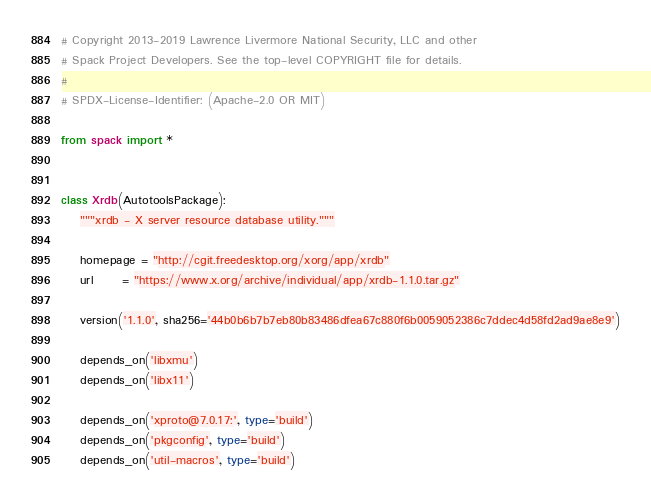<code> <loc_0><loc_0><loc_500><loc_500><_Python_># Copyright 2013-2019 Lawrence Livermore National Security, LLC and other
# Spack Project Developers. See the top-level COPYRIGHT file for details.
#
# SPDX-License-Identifier: (Apache-2.0 OR MIT)

from spack import *


class Xrdb(AutotoolsPackage):
    """xrdb - X server resource database utility."""

    homepage = "http://cgit.freedesktop.org/xorg/app/xrdb"
    url      = "https://www.x.org/archive/individual/app/xrdb-1.1.0.tar.gz"

    version('1.1.0', sha256='44b0b6b7b7eb80b83486dfea67c880f6b0059052386c7ddec4d58fd2ad9ae8e9')

    depends_on('libxmu')
    depends_on('libx11')

    depends_on('xproto@7.0.17:', type='build')
    depends_on('pkgconfig', type='build')
    depends_on('util-macros', type='build')
</code> 